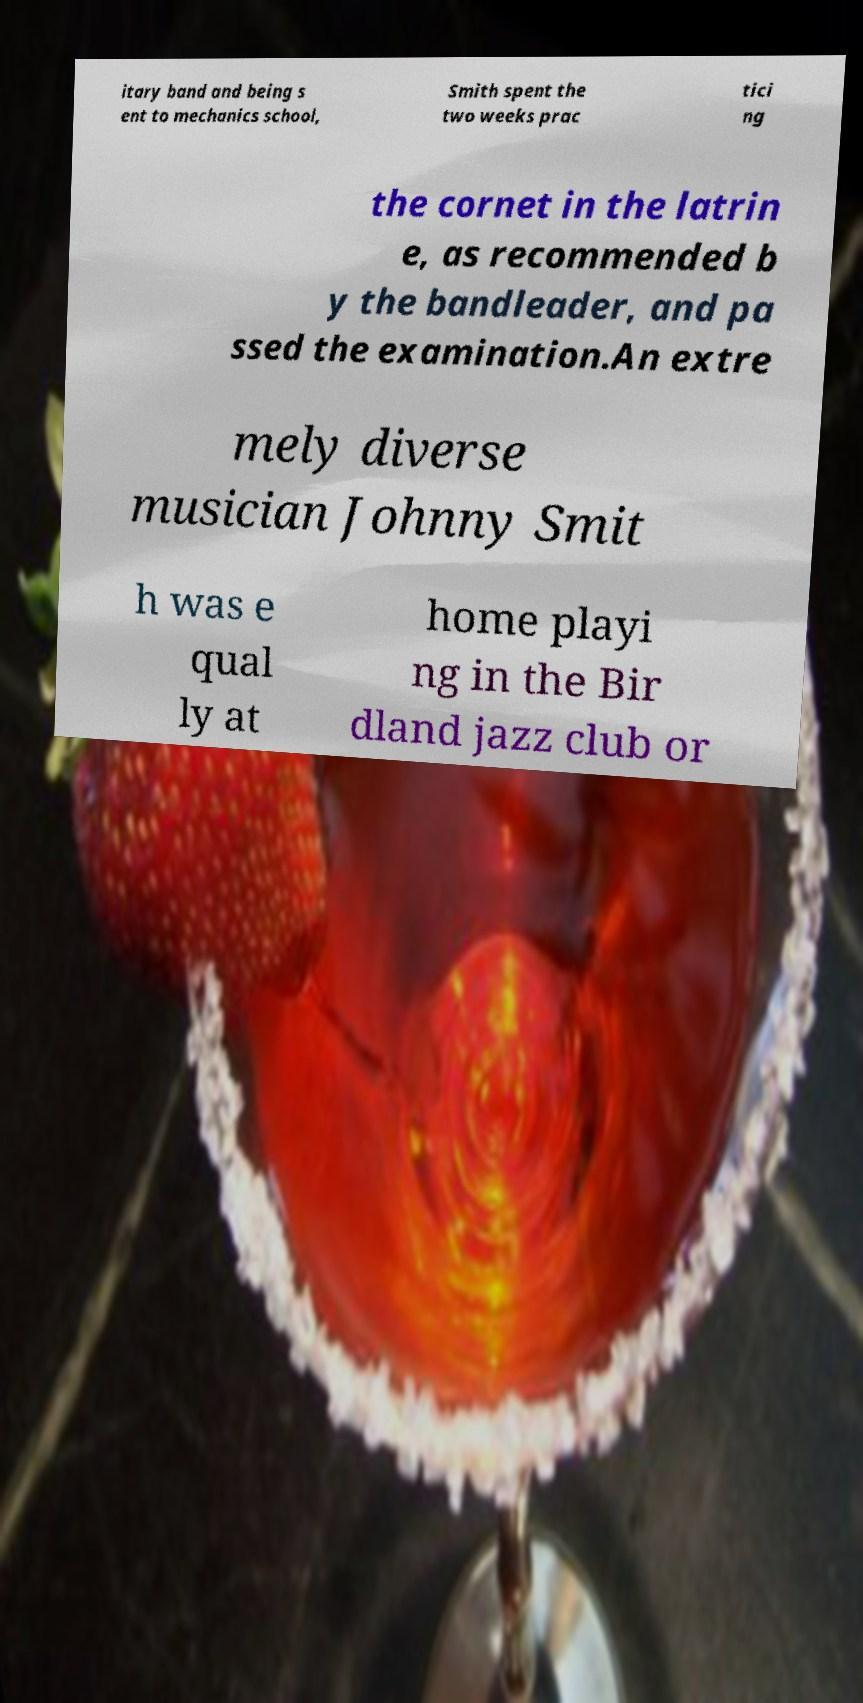Could you extract and type out the text from this image? itary band and being s ent to mechanics school, Smith spent the two weeks prac tici ng the cornet in the latrin e, as recommended b y the bandleader, and pa ssed the examination.An extre mely diverse musician Johnny Smit h was e qual ly at home playi ng in the Bir dland jazz club or 